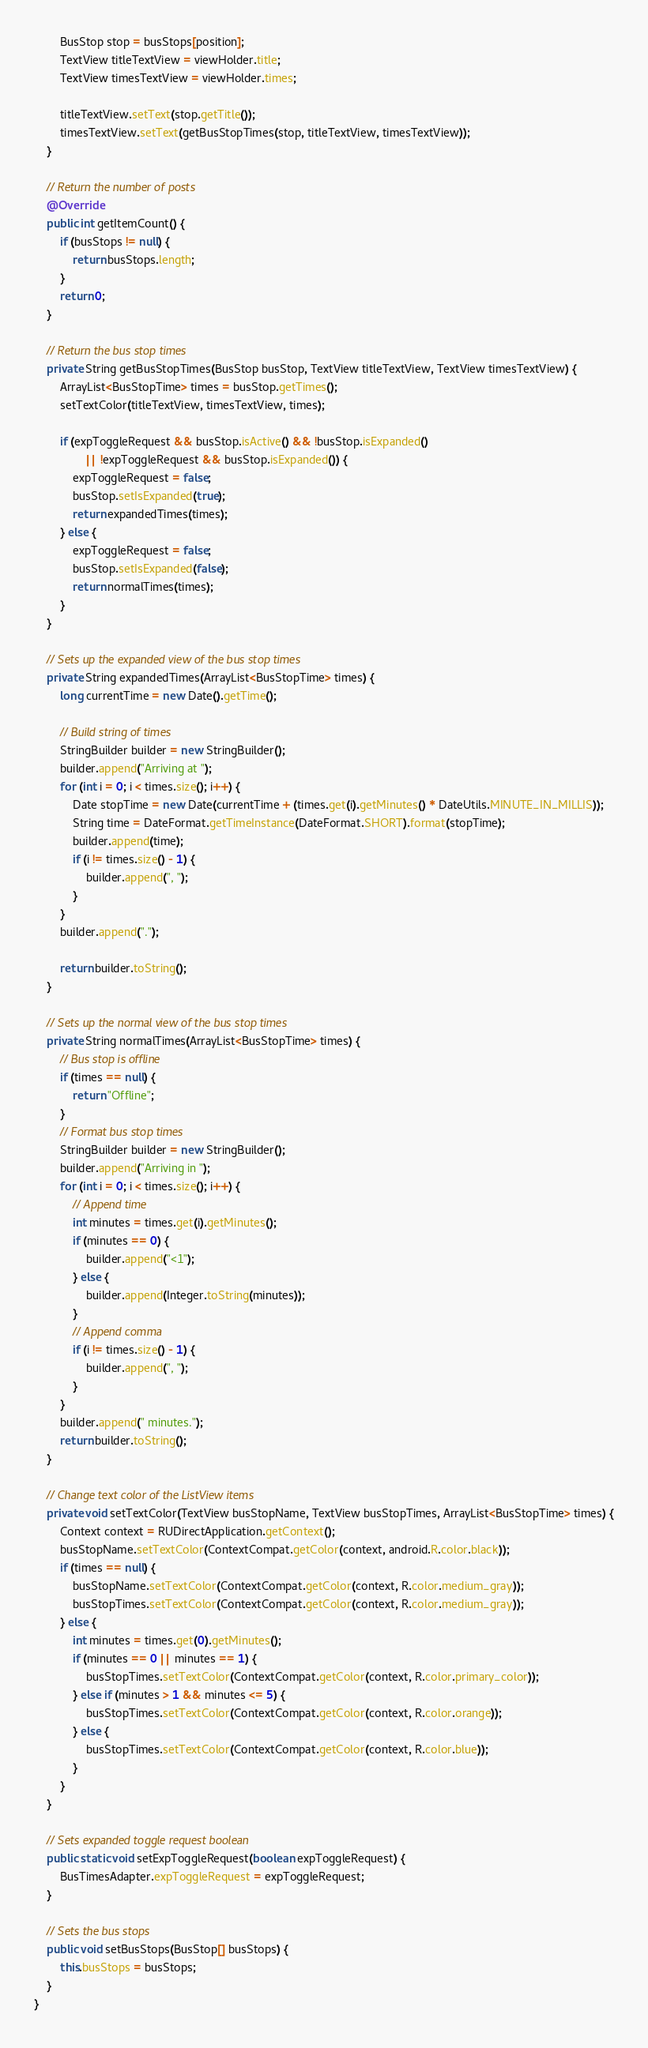<code> <loc_0><loc_0><loc_500><loc_500><_Java_>        BusStop stop = busStops[position];
        TextView titleTextView = viewHolder.title;
        TextView timesTextView = viewHolder.times;

        titleTextView.setText(stop.getTitle());
        timesTextView.setText(getBusStopTimes(stop, titleTextView, timesTextView));
    }

    // Return the number of posts
    @Override
    public int getItemCount() {
        if (busStops != null) {
            return busStops.length;
        }
        return 0;
    }

    // Return the bus stop times
    private String getBusStopTimes(BusStop busStop, TextView titleTextView, TextView timesTextView) {
        ArrayList<BusStopTime> times = busStop.getTimes();
        setTextColor(titleTextView, timesTextView, times);

        if (expToggleRequest && busStop.isActive() && !busStop.isExpanded()
                || !expToggleRequest && busStop.isExpanded()) {
            expToggleRequest = false;
            busStop.setIsExpanded(true);
            return expandedTimes(times);
        } else {
            expToggleRequest = false;
            busStop.setIsExpanded(false);
            return normalTimes(times);
        }
    }

    // Sets up the expanded view of the bus stop times
    private String expandedTimes(ArrayList<BusStopTime> times) {
        long currentTime = new Date().getTime();

        // Build string of times
        StringBuilder builder = new StringBuilder();
        builder.append("Arriving at ");
        for (int i = 0; i < times.size(); i++) {
            Date stopTime = new Date(currentTime + (times.get(i).getMinutes() * DateUtils.MINUTE_IN_MILLIS));
            String time = DateFormat.getTimeInstance(DateFormat.SHORT).format(stopTime);
            builder.append(time);
            if (i != times.size() - 1) {
                builder.append(", ");
            }
        }
        builder.append(".");

        return builder.toString();
    }

    // Sets up the normal view of the bus stop times
    private String normalTimes(ArrayList<BusStopTime> times) {
        // Bus stop is offline
        if (times == null) {
            return "Offline";
        }
        // Format bus stop times
        StringBuilder builder = new StringBuilder();
        builder.append("Arriving in ");
        for (int i = 0; i < times.size(); i++) {
            // Append time
            int minutes = times.get(i).getMinutes();
            if (minutes == 0) {
                builder.append("<1");
            } else {
                builder.append(Integer.toString(minutes));
            }
            // Append comma
            if (i != times.size() - 1) {
                builder.append(", ");
            }
        }
        builder.append(" minutes.");
        return builder.toString();
    }

    // Change text color of the ListView items
    private void setTextColor(TextView busStopName, TextView busStopTimes, ArrayList<BusStopTime> times) {
        Context context = RUDirectApplication.getContext();
        busStopName.setTextColor(ContextCompat.getColor(context, android.R.color.black));
        if (times == null) {
            busStopName.setTextColor(ContextCompat.getColor(context, R.color.medium_gray));
            busStopTimes.setTextColor(ContextCompat.getColor(context, R.color.medium_gray));
        } else {
            int minutes = times.get(0).getMinutes();
            if (minutes == 0 || minutes == 1) {
                busStopTimes.setTextColor(ContextCompat.getColor(context, R.color.primary_color));
            } else if (minutes > 1 && minutes <= 5) {
                busStopTimes.setTextColor(ContextCompat.getColor(context, R.color.orange));
            } else {
                busStopTimes.setTextColor(ContextCompat.getColor(context, R.color.blue));
            }
        }
    }

    // Sets expanded toggle request boolean
    public static void setExpToggleRequest(boolean expToggleRequest) {
        BusTimesAdapter.expToggleRequest = expToggleRequest;
    }

    // Sets the bus stops
    public void setBusStops(BusStop[] busStops) {
        this.busStops = busStops;
    }
}</code> 